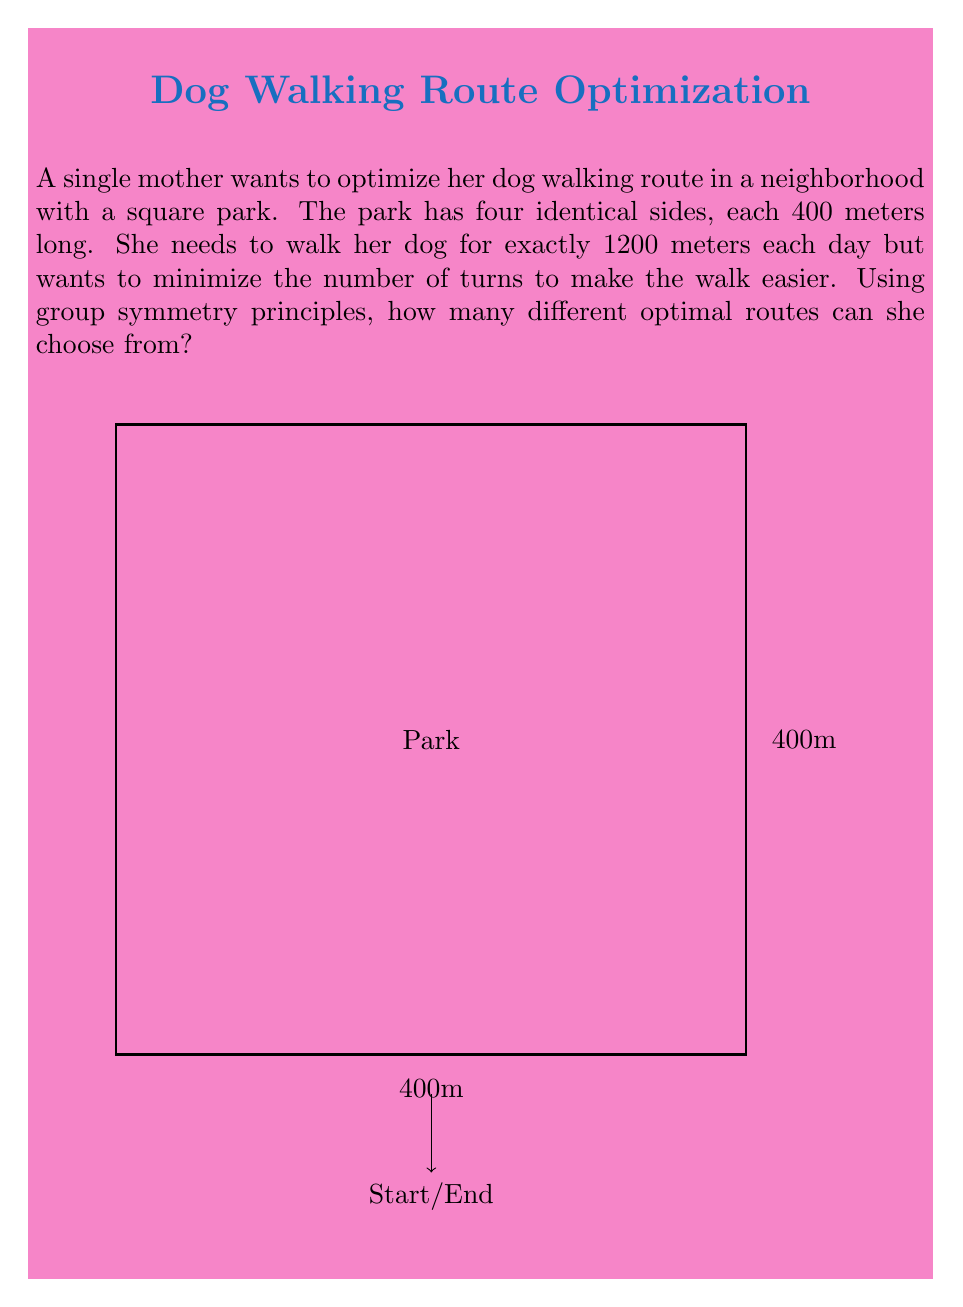Could you help me with this problem? Let's approach this step-by-step using group symmetry principles:

1) The park forms a square, which has the symmetry group $D_4$ (dihedral group of order 8).

2) An optimal route that minimizes turns would involve walking around the park exactly three times, as $3 \times 400m = 1200m$.

3) There are two types of symmetries we need to consider:
   a) Rotational symmetry (4 rotations including identity)
   b) Reflection symmetry (4 reflections)

4) For each starting point, there are two directions to walk (clockwise or counterclockwise). This gives us 2 options.

5) Due to rotational symmetry, we can start at any of the 4 corners. This multiplies our options by 4.

6) However, walking clockwise from one corner is equivalent to walking counterclockwise from the opposite corner. This means we've double-counted, so we need to divide by 2.

7) The reflection symmetries don't add any new distinct routes in this case.

8) Therefore, the total number of distinct optimal routes is:

   $$ \text{Number of routes} = 2 \times 4 \div 2 = 4 $$

This result aligns with the order of the cyclic subgroup $C_4$ of $D_4$, which corresponds to the rotational symmetries of the square.
Answer: 4 routes 